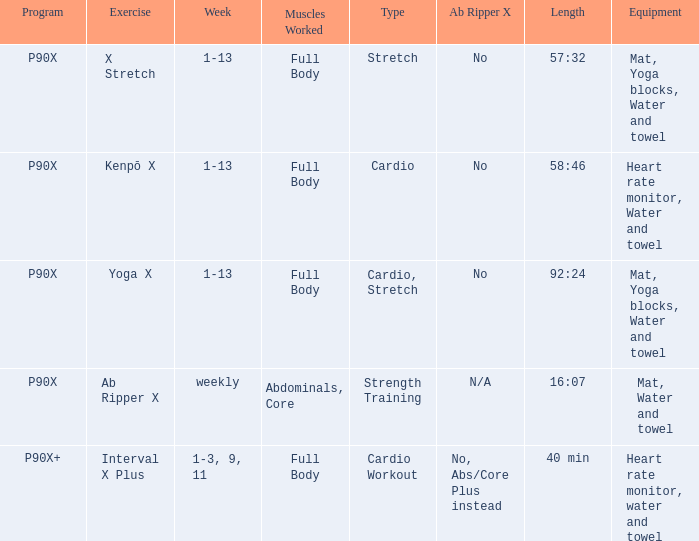What is the ab ripper x when exercise is x stretch? No. 